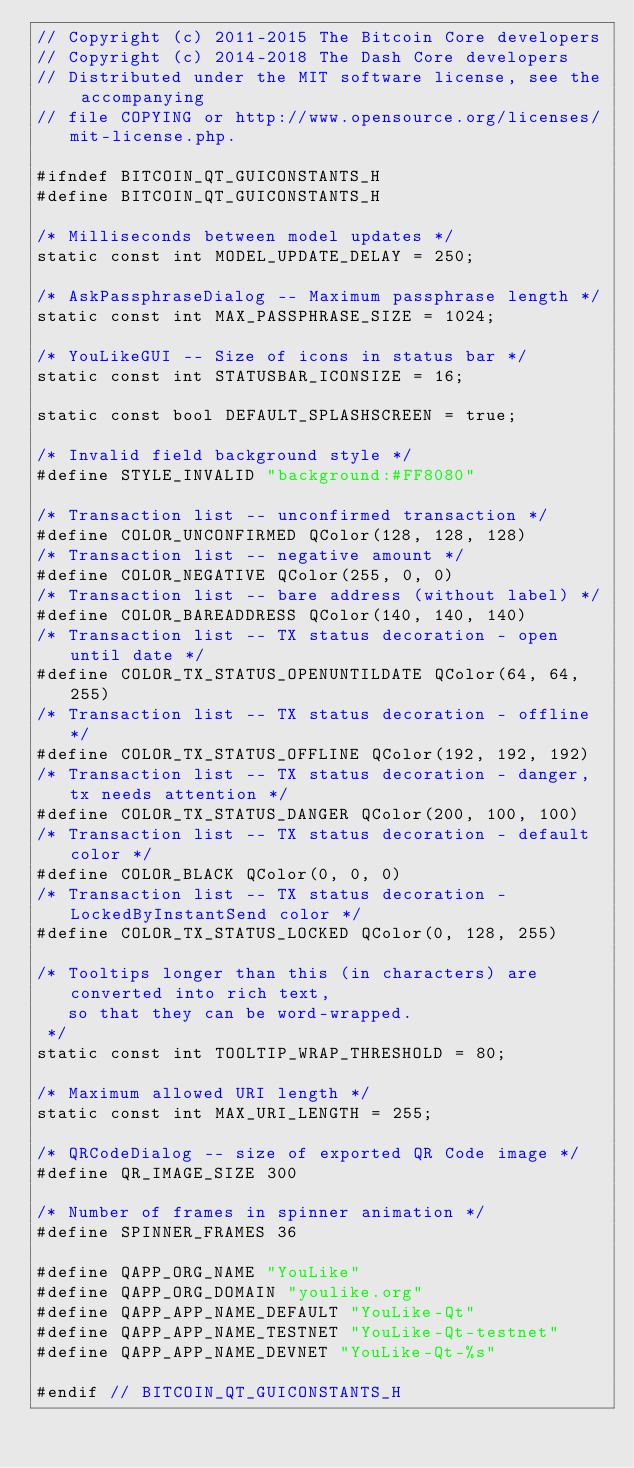<code> <loc_0><loc_0><loc_500><loc_500><_C_>// Copyright (c) 2011-2015 The Bitcoin Core developers
// Copyright (c) 2014-2018 The Dash Core developers
// Distributed under the MIT software license, see the accompanying
// file COPYING or http://www.opensource.org/licenses/mit-license.php.

#ifndef BITCOIN_QT_GUICONSTANTS_H
#define BITCOIN_QT_GUICONSTANTS_H

/* Milliseconds between model updates */
static const int MODEL_UPDATE_DELAY = 250;

/* AskPassphraseDialog -- Maximum passphrase length */
static const int MAX_PASSPHRASE_SIZE = 1024;

/* YouLikeGUI -- Size of icons in status bar */
static const int STATUSBAR_ICONSIZE = 16;

static const bool DEFAULT_SPLASHSCREEN = true;

/* Invalid field background style */
#define STYLE_INVALID "background:#FF8080"

/* Transaction list -- unconfirmed transaction */
#define COLOR_UNCONFIRMED QColor(128, 128, 128)
/* Transaction list -- negative amount */
#define COLOR_NEGATIVE QColor(255, 0, 0)
/* Transaction list -- bare address (without label) */
#define COLOR_BAREADDRESS QColor(140, 140, 140)
/* Transaction list -- TX status decoration - open until date */
#define COLOR_TX_STATUS_OPENUNTILDATE QColor(64, 64, 255)
/* Transaction list -- TX status decoration - offline */
#define COLOR_TX_STATUS_OFFLINE QColor(192, 192, 192)
/* Transaction list -- TX status decoration - danger, tx needs attention */
#define COLOR_TX_STATUS_DANGER QColor(200, 100, 100)
/* Transaction list -- TX status decoration - default color */
#define COLOR_BLACK QColor(0, 0, 0)
/* Transaction list -- TX status decoration - LockedByInstantSend color */
#define COLOR_TX_STATUS_LOCKED QColor(0, 128, 255)

/* Tooltips longer than this (in characters) are converted into rich text,
   so that they can be word-wrapped.
 */
static const int TOOLTIP_WRAP_THRESHOLD = 80;

/* Maximum allowed URI length */
static const int MAX_URI_LENGTH = 255;

/* QRCodeDialog -- size of exported QR Code image */
#define QR_IMAGE_SIZE 300

/* Number of frames in spinner animation */
#define SPINNER_FRAMES 36

#define QAPP_ORG_NAME "YouLike"
#define QAPP_ORG_DOMAIN "youlike.org"
#define QAPP_APP_NAME_DEFAULT "YouLike-Qt"
#define QAPP_APP_NAME_TESTNET "YouLike-Qt-testnet"
#define QAPP_APP_NAME_DEVNET "YouLike-Qt-%s"

#endif // BITCOIN_QT_GUICONSTANTS_H
</code> 